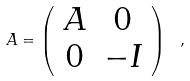<formula> <loc_0><loc_0><loc_500><loc_500>A = \left ( \begin{array} { c c } A & 0 \\ 0 & - I \end{array} \right ) \ ,</formula> 